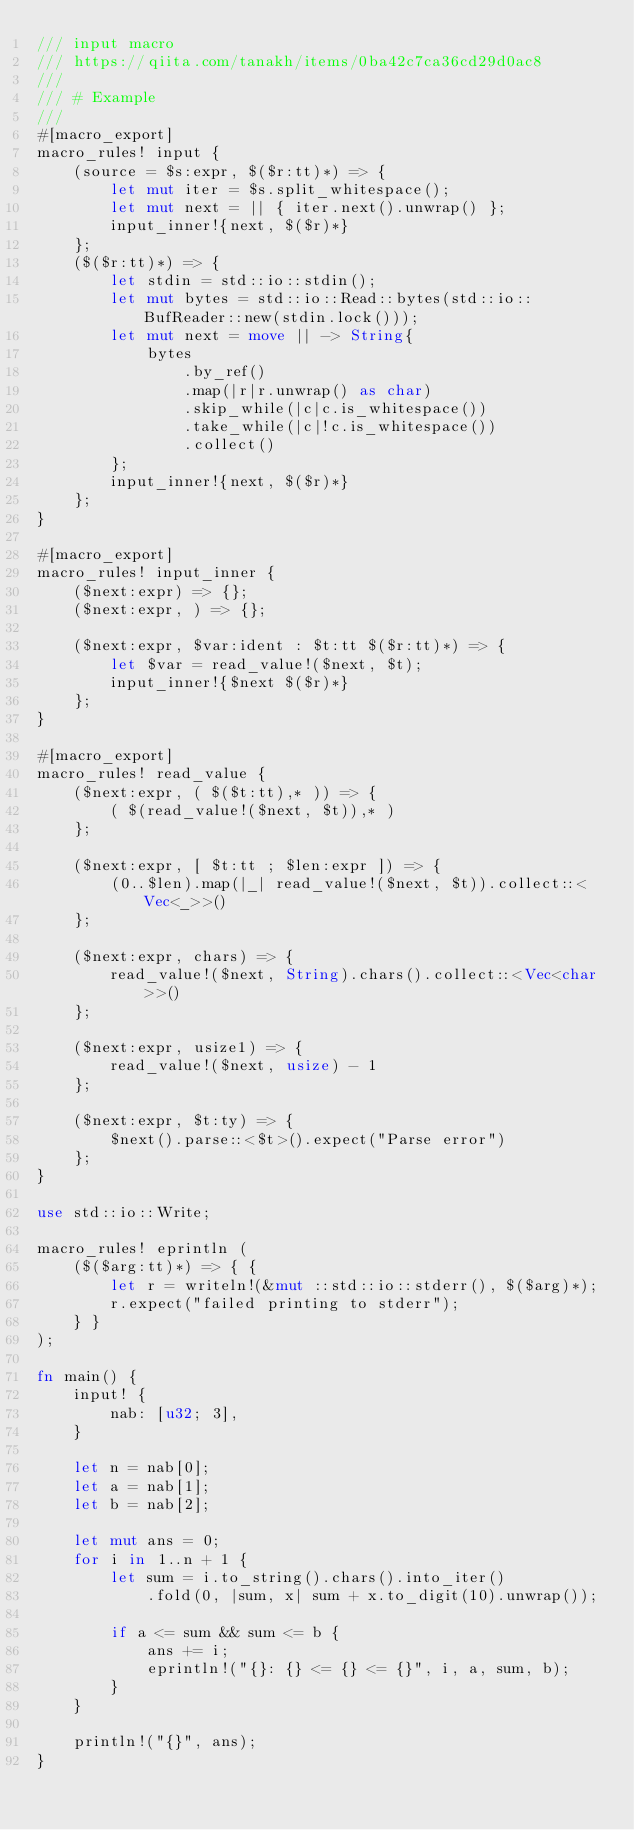Convert code to text. <code><loc_0><loc_0><loc_500><loc_500><_Rust_>/// input macro
/// https://qiita.com/tanakh/items/0ba42c7ca36cd29d0ac8
///
/// # Example
///
#[macro_export]
macro_rules! input {
    (source = $s:expr, $($r:tt)*) => {
        let mut iter = $s.split_whitespace();
        let mut next = || { iter.next().unwrap() };
        input_inner!{next, $($r)*}
    };
    ($($r:tt)*) => {
        let stdin = std::io::stdin();
        let mut bytes = std::io::Read::bytes(std::io::BufReader::new(stdin.lock()));
        let mut next = move || -> String{
            bytes
                .by_ref()
                .map(|r|r.unwrap() as char)
                .skip_while(|c|c.is_whitespace())
                .take_while(|c|!c.is_whitespace())
                .collect()
        };
        input_inner!{next, $($r)*}
    };
}

#[macro_export]
macro_rules! input_inner {
    ($next:expr) => {};
    ($next:expr, ) => {};

    ($next:expr, $var:ident : $t:tt $($r:tt)*) => {
        let $var = read_value!($next, $t);
        input_inner!{$next $($r)*}
    };
}

#[macro_export]
macro_rules! read_value {
    ($next:expr, ( $($t:tt),* )) => {
        ( $(read_value!($next, $t)),* )
    };

    ($next:expr, [ $t:tt ; $len:expr ]) => {
        (0..$len).map(|_| read_value!($next, $t)).collect::<Vec<_>>()
    };

    ($next:expr, chars) => {
        read_value!($next, String).chars().collect::<Vec<char>>()
    };

    ($next:expr, usize1) => {
        read_value!($next, usize) - 1
    };

    ($next:expr, $t:ty) => {
        $next().parse::<$t>().expect("Parse error")
    };
}

use std::io::Write;

macro_rules! eprintln (
    ($($arg:tt)*) => { {
        let r = writeln!(&mut ::std::io::stderr(), $($arg)*);
        r.expect("failed printing to stderr");
    } }
);

fn main() {
    input! {
        nab: [u32; 3],
    }

    let n = nab[0];
    let a = nab[1];
    let b = nab[2];

    let mut ans = 0;
    for i in 1..n + 1 {
        let sum = i.to_string().chars().into_iter()
            .fold(0, |sum, x| sum + x.to_digit(10).unwrap());

        if a <= sum && sum <= b {
            ans += i;
            eprintln!("{}: {} <= {} <= {}", i, a, sum, b);
        }
    }

    println!("{}", ans);
}

</code> 